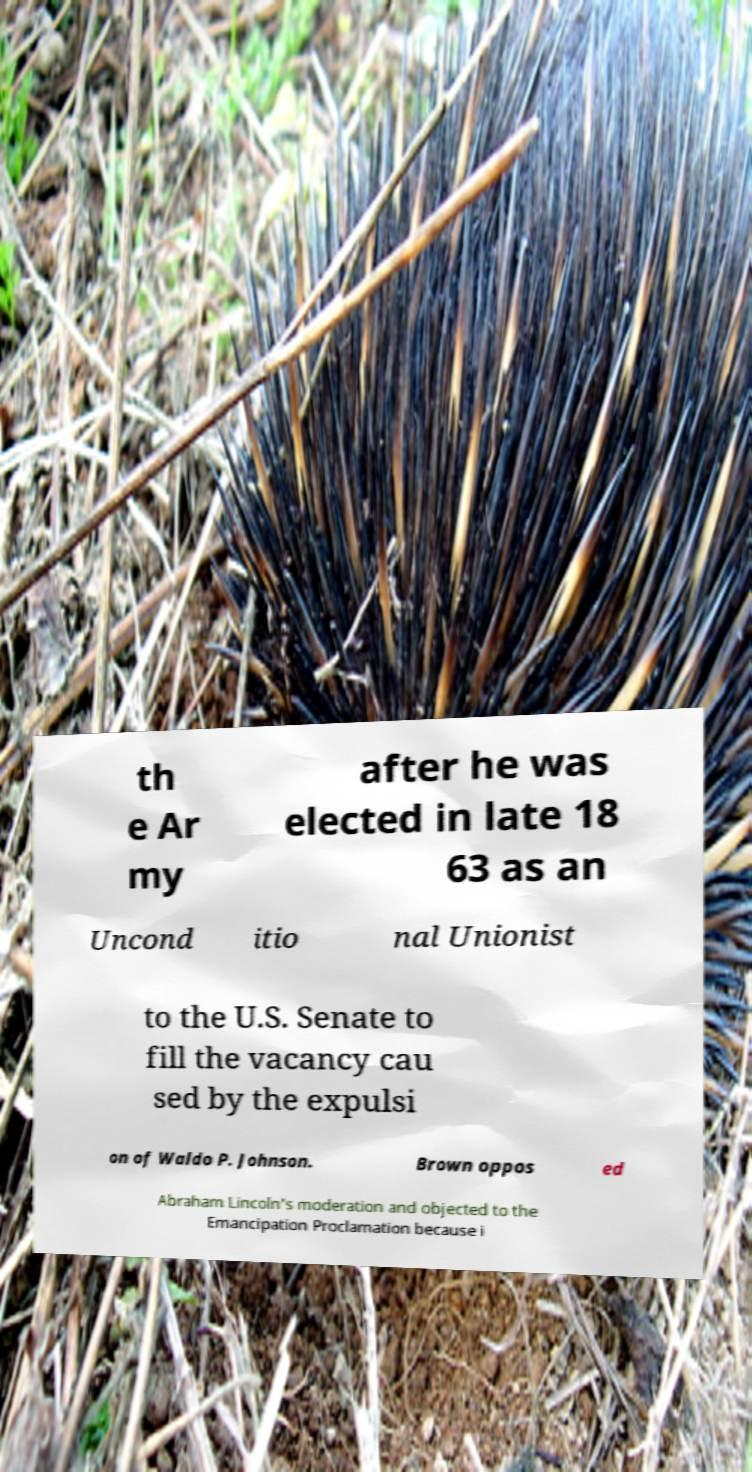Can you read and provide the text displayed in the image?This photo seems to have some interesting text. Can you extract and type it out for me? th e Ar my after he was elected in late 18 63 as an Uncond itio nal Unionist to the U.S. Senate to fill the vacancy cau sed by the expulsi on of Waldo P. Johnson. Brown oppos ed Abraham Lincoln's moderation and objected to the Emancipation Proclamation because i 